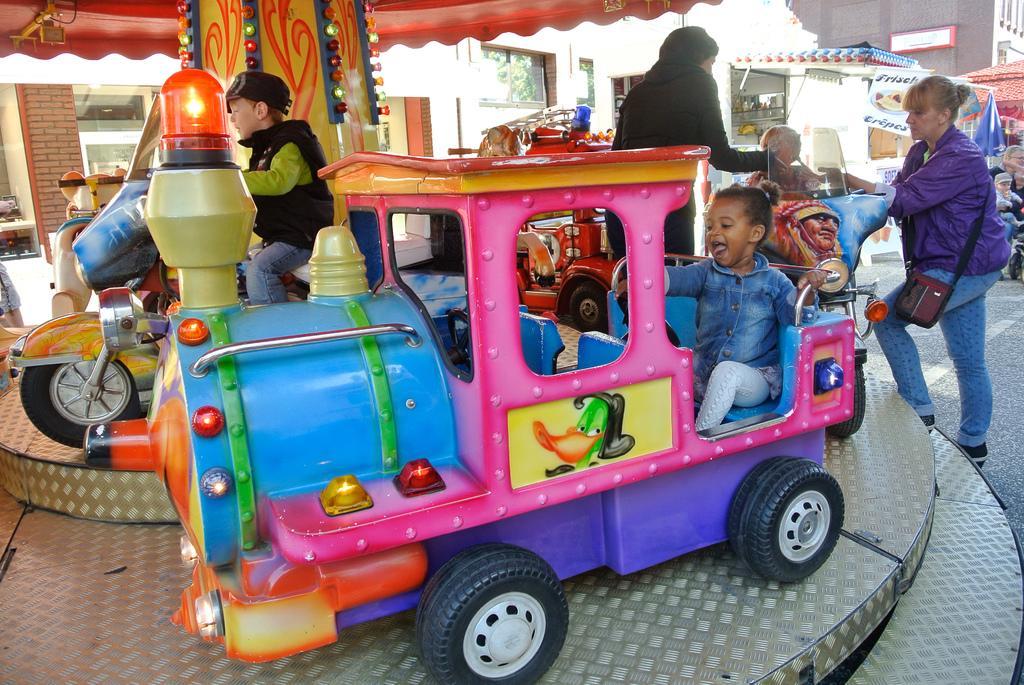Can you describe this image briefly? This image is taken outdoors. At the bottom of the image there is a stage. In the middle of the image there is a carnival train. A few kids are sitting on the trains. A woman is standing on the stage. In the background there is a building. There are two stalls. On the right side of the image there is a building. There are many boards with text on them. A kid is walking on the road and there is a closed umbrella. A woman is standing. 